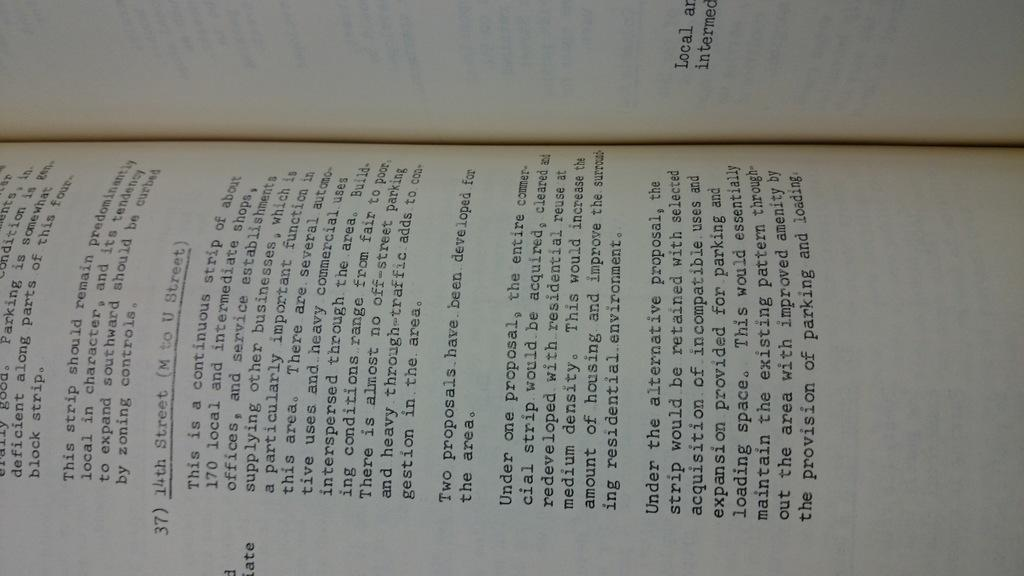<image>
Offer a succinct explanation of the picture presented. An open book with a page describing proposals for developing a strip of a city. 